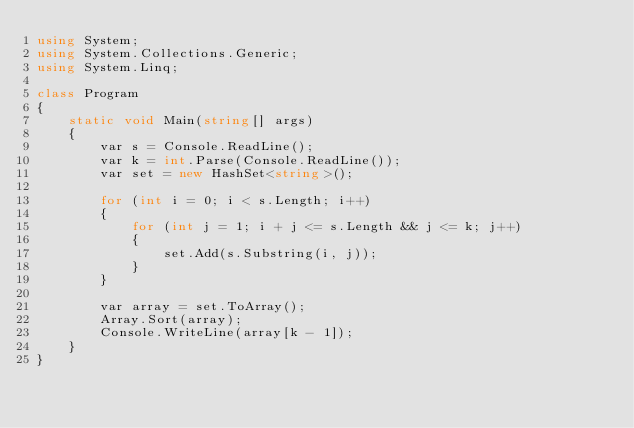Convert code to text. <code><loc_0><loc_0><loc_500><loc_500><_C#_>using System;
using System.Collections.Generic;
using System.Linq;

class Program
{
    static void Main(string[] args)
    {
        var s = Console.ReadLine();
        var k = int.Parse(Console.ReadLine());
        var set = new HashSet<string>();

        for (int i = 0; i < s.Length; i++)
        {
            for (int j = 1; i + j <= s.Length && j <= k; j++)
            {
                set.Add(s.Substring(i, j));
            }
        }

        var array = set.ToArray();
        Array.Sort(array);
        Console.WriteLine(array[k - 1]);
    }
}
</code> 